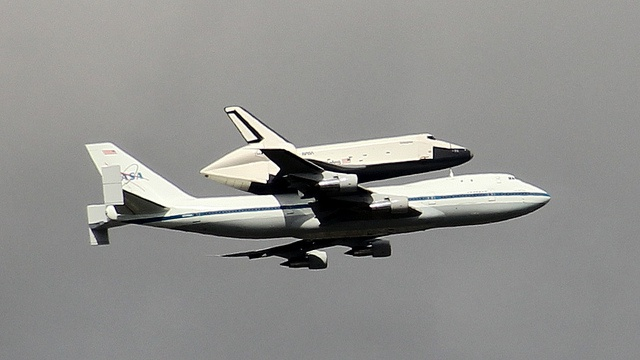Describe the objects in this image and their specific colors. I can see a airplane in darkgray, ivory, black, and gray tones in this image. 